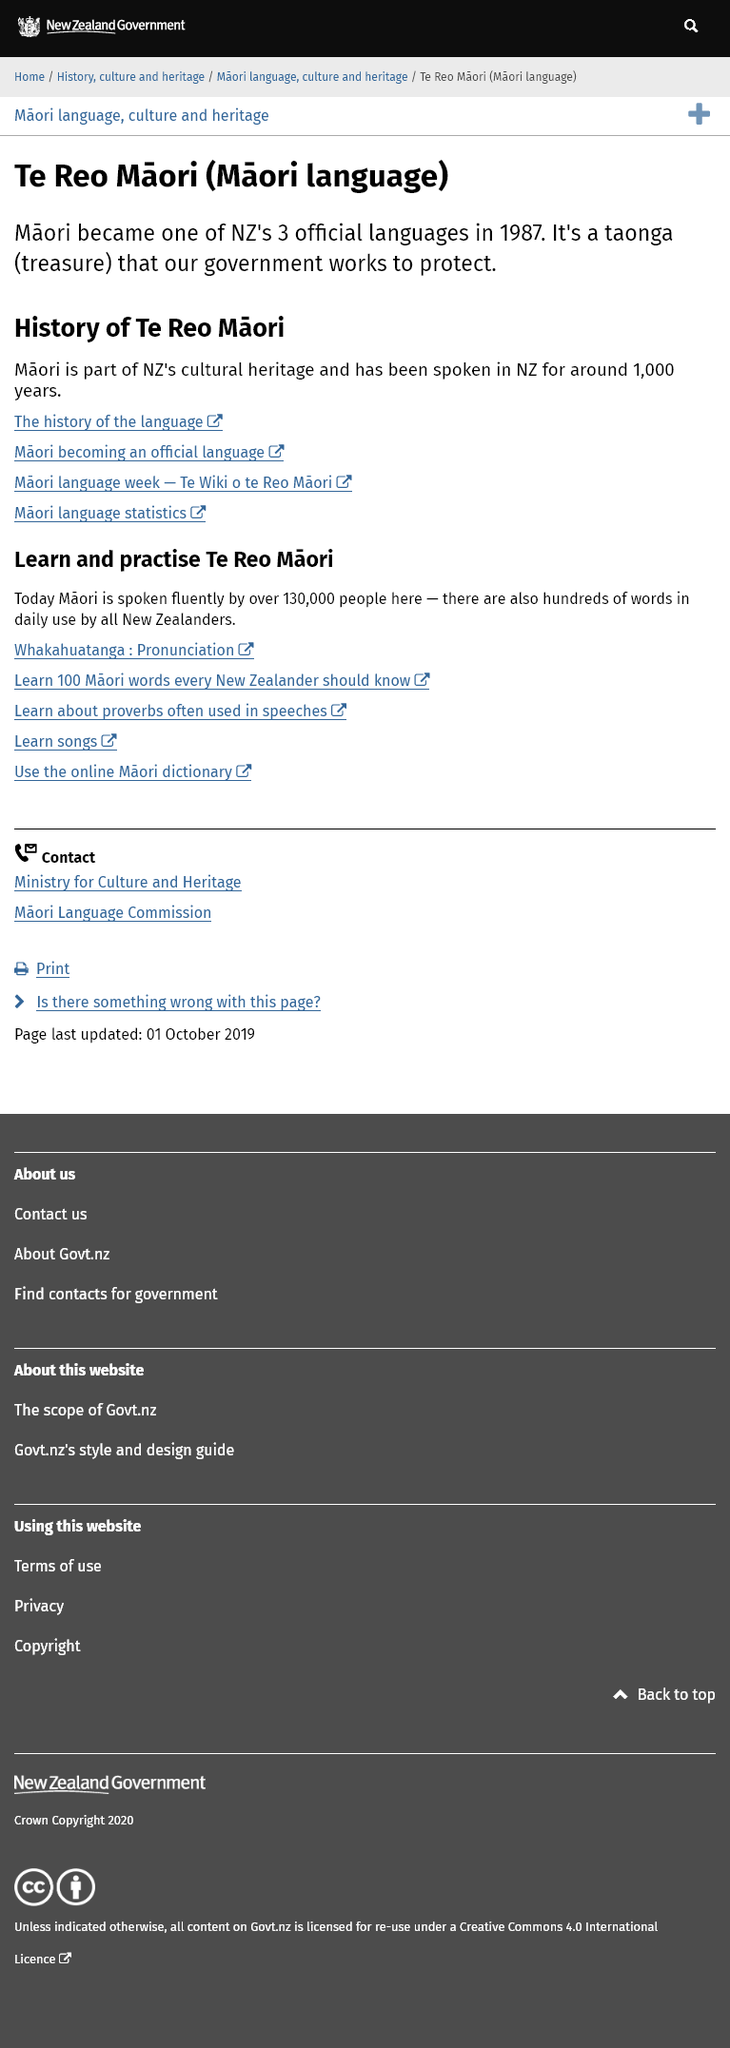List a handful of essential elements in this visual. To obtain data on the Maori language, one can click on the link labeled "Maori language statistics. Yes, the government is actively working to safeguard the Maori language. In 1987, Maori was declared one of New Zealand's three official languages, and it has been spoken in the country for approximately 1,000 years. 